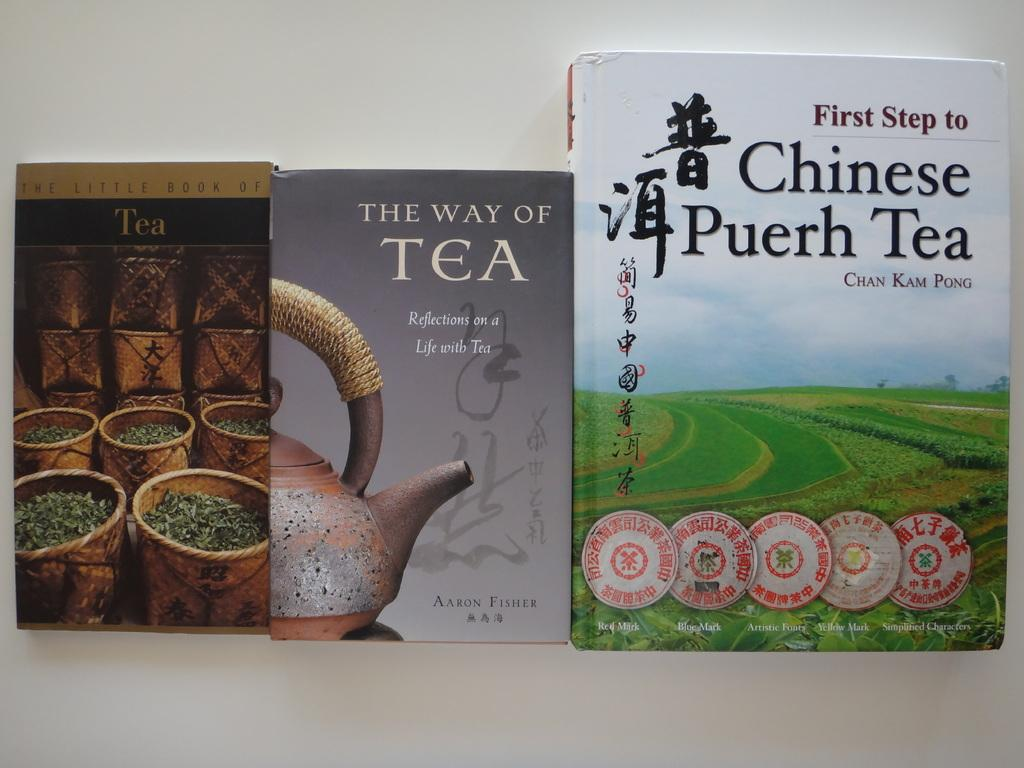<image>
Describe the image concisely. All three of the books pictured are about tea. 